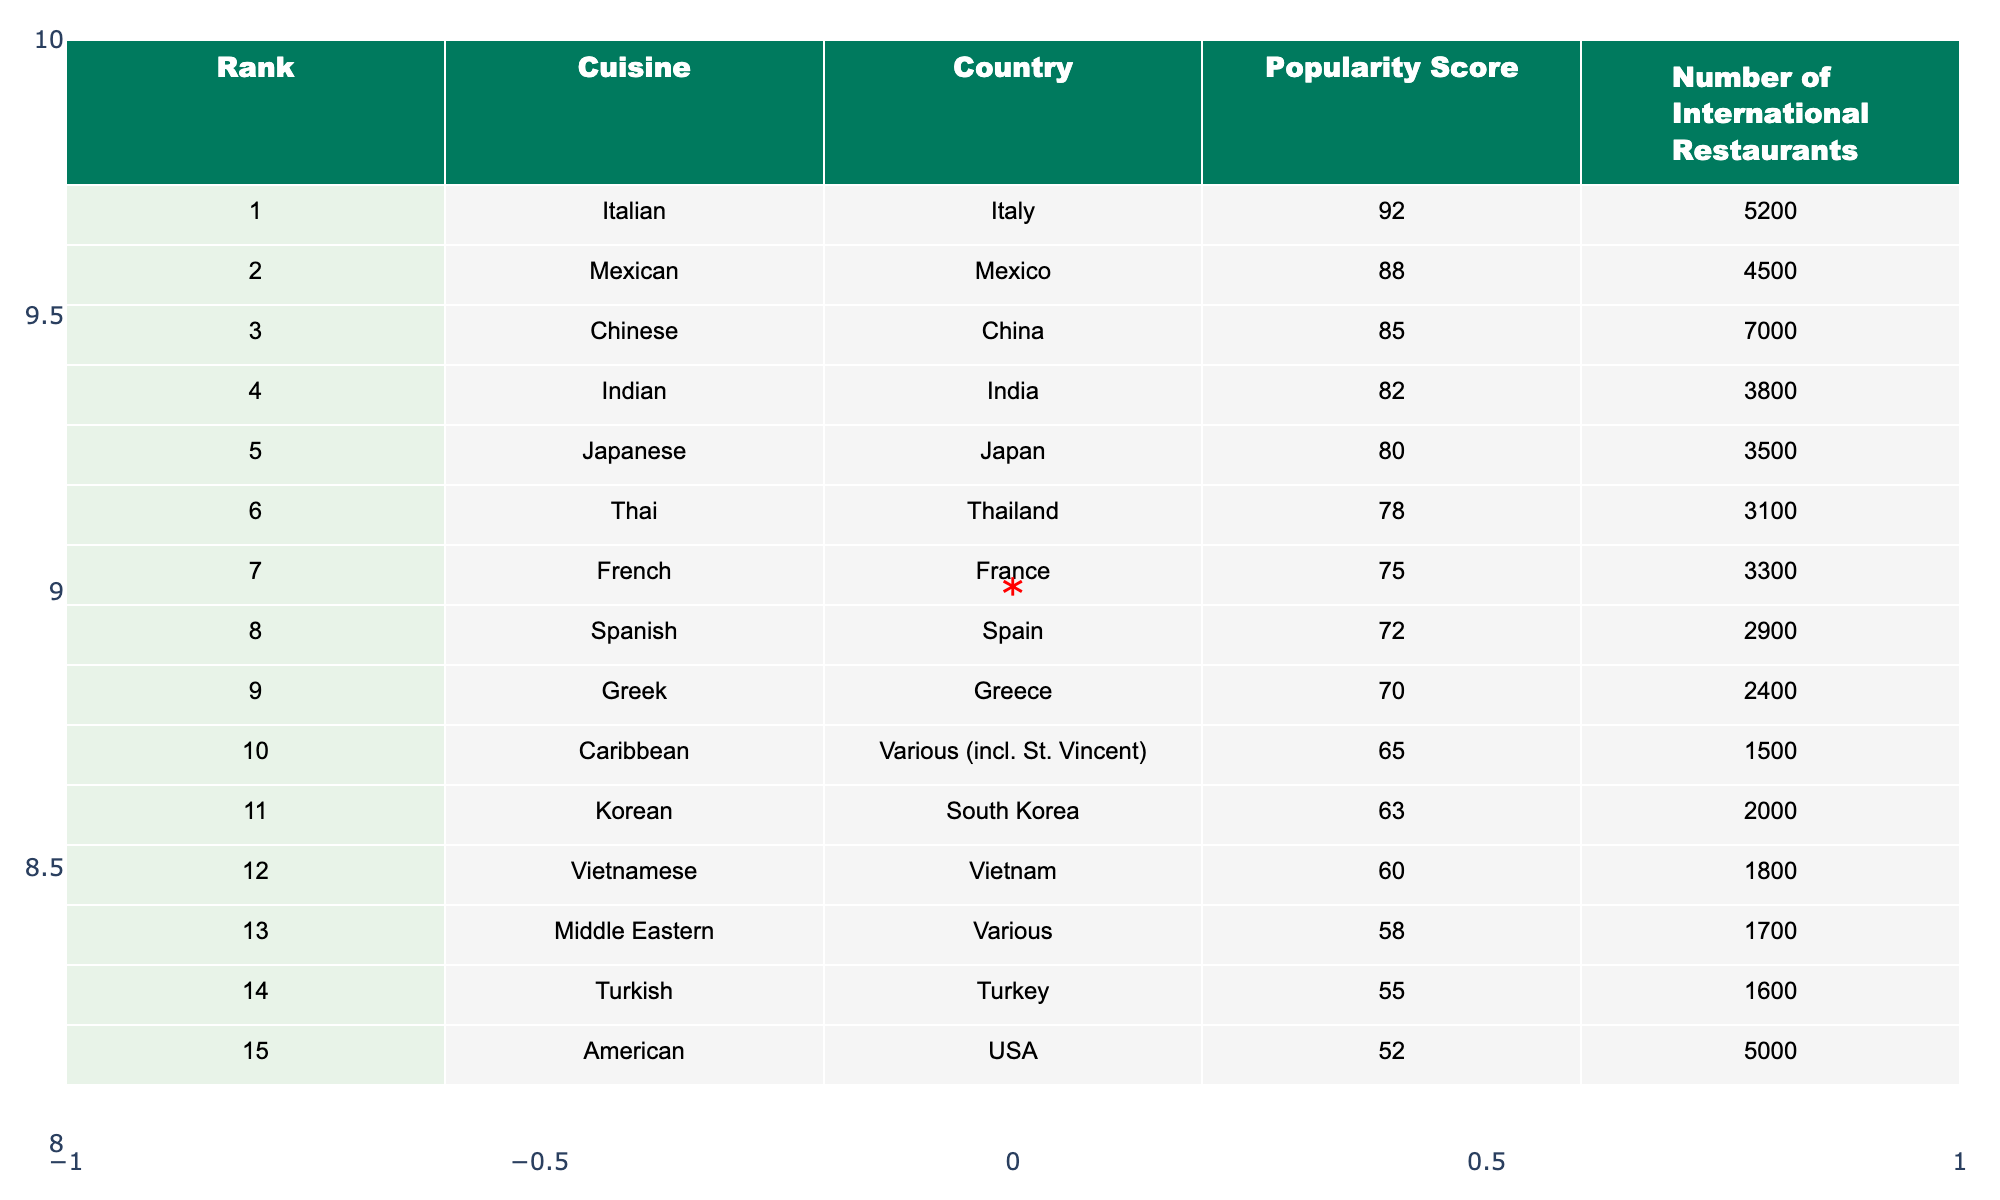What's the popularity score of Italian cuisine? The table indicates the popularity score of Italian cuisine is found in the row corresponding to Italian, which shows a score of 92.
Answer: 92 Which cuisine has the lowest popularity score? By looking at the table, the lowest popularity score is associated with Turkish cuisine, which has a score of 55.
Answer: 55 How many international restaurants serve Caribbean cuisine? The number of international restaurants serving Caribbean cuisine can be found in the corresponding row, which indicates there are 1,500 restaurants.
Answer: 1500 What is the difference in popularity scores between Chinese and Indian cuisines? To find the difference, subtract the Indian cuisine score (82) from the Chinese cuisine score (85): 85 - 82 = 3.
Answer: 3 What is the average popularity score of the top three cuisines? The scores of the top three cuisines are 92 (Italian), 88 (Mexican), and 85 (Chinese). Adding these scores gives 265, and dividing by 3 results in an average of 88.33.
Answer: 88.33 Is there a cuisine from the Caribbean listed in the top ten? Yes, Caribbean cuisine is listed in the table in the 10th position, confirming its presence in the top ten cuisines by popularity.
Answer: Yes Which cuisine has more international restaurants, Spanish or Greek? Spanish cuisine has 2,900 restaurants and Greek cuisine has 2,400. Comparing these values shows that Spanish cuisine has more international restaurants than Greek cuisine.
Answer: Spanish What total number of international restaurants serve Italian, Mexican, and Indian cuisines combined? The total number of restaurants for Italian (5,200), Mexican (4,500), and Indian (3,800) cuisines is: 5,200 + 4,500 + 3,800 = 13,500.
Answer: 13500 Which country has the highest popularity score among cuisines listed? The country with the highest popularity score belongs to Italy, as indicated by the highest score of 92 for Italian cuisine.
Answer: Italy Does Caribbean cuisine rank higher than American cuisine in popularity? Caribbean cuisine ranks 10th with a popularity score of 65, while American cuisine ranks 15th with a score of 52. Thus, Caribbean cuisine does rank higher than American.
Answer: Yes 